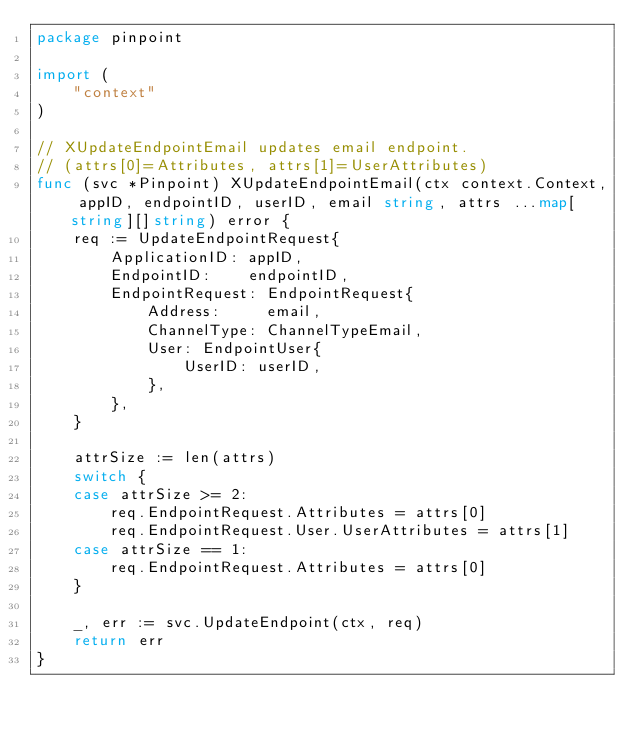Convert code to text. <code><loc_0><loc_0><loc_500><loc_500><_Go_>package pinpoint

import (
	"context"
)

// XUpdateEndpointEmail updates email endpoint.
// (attrs[0]=Attributes, attrs[1]=UserAttributes)
func (svc *Pinpoint) XUpdateEndpointEmail(ctx context.Context, appID, endpointID, userID, email string, attrs ...map[string][]string) error {
	req := UpdateEndpointRequest{
		ApplicationID: appID,
		EndpointID:    endpointID,
		EndpointRequest: EndpointRequest{
			Address:     email,
			ChannelType: ChannelTypeEmail,
			User: EndpointUser{
				UserID: userID,
			},
		},
	}

	attrSize := len(attrs)
	switch {
	case attrSize >= 2:
		req.EndpointRequest.Attributes = attrs[0]
		req.EndpointRequest.User.UserAttributes = attrs[1]
	case attrSize == 1:
		req.EndpointRequest.Attributes = attrs[0]
	}

	_, err := svc.UpdateEndpoint(ctx, req)
	return err
}
</code> 